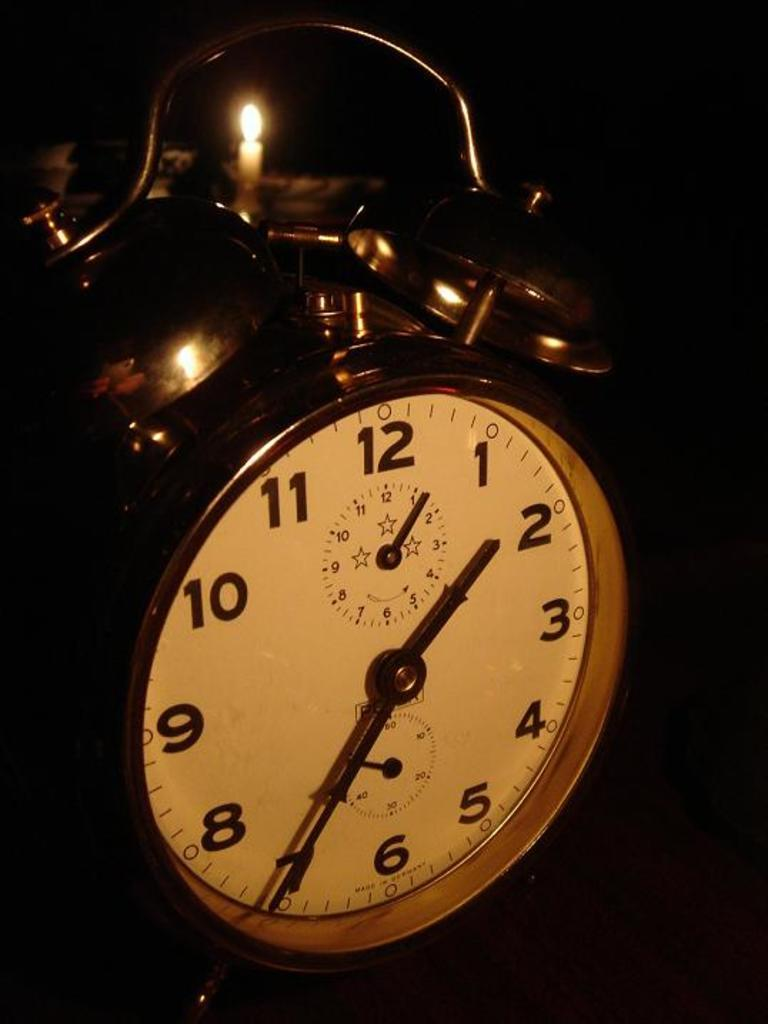<image>
Summarize the visual content of the image. A clock with 1 to 12 written on it 